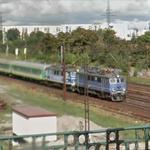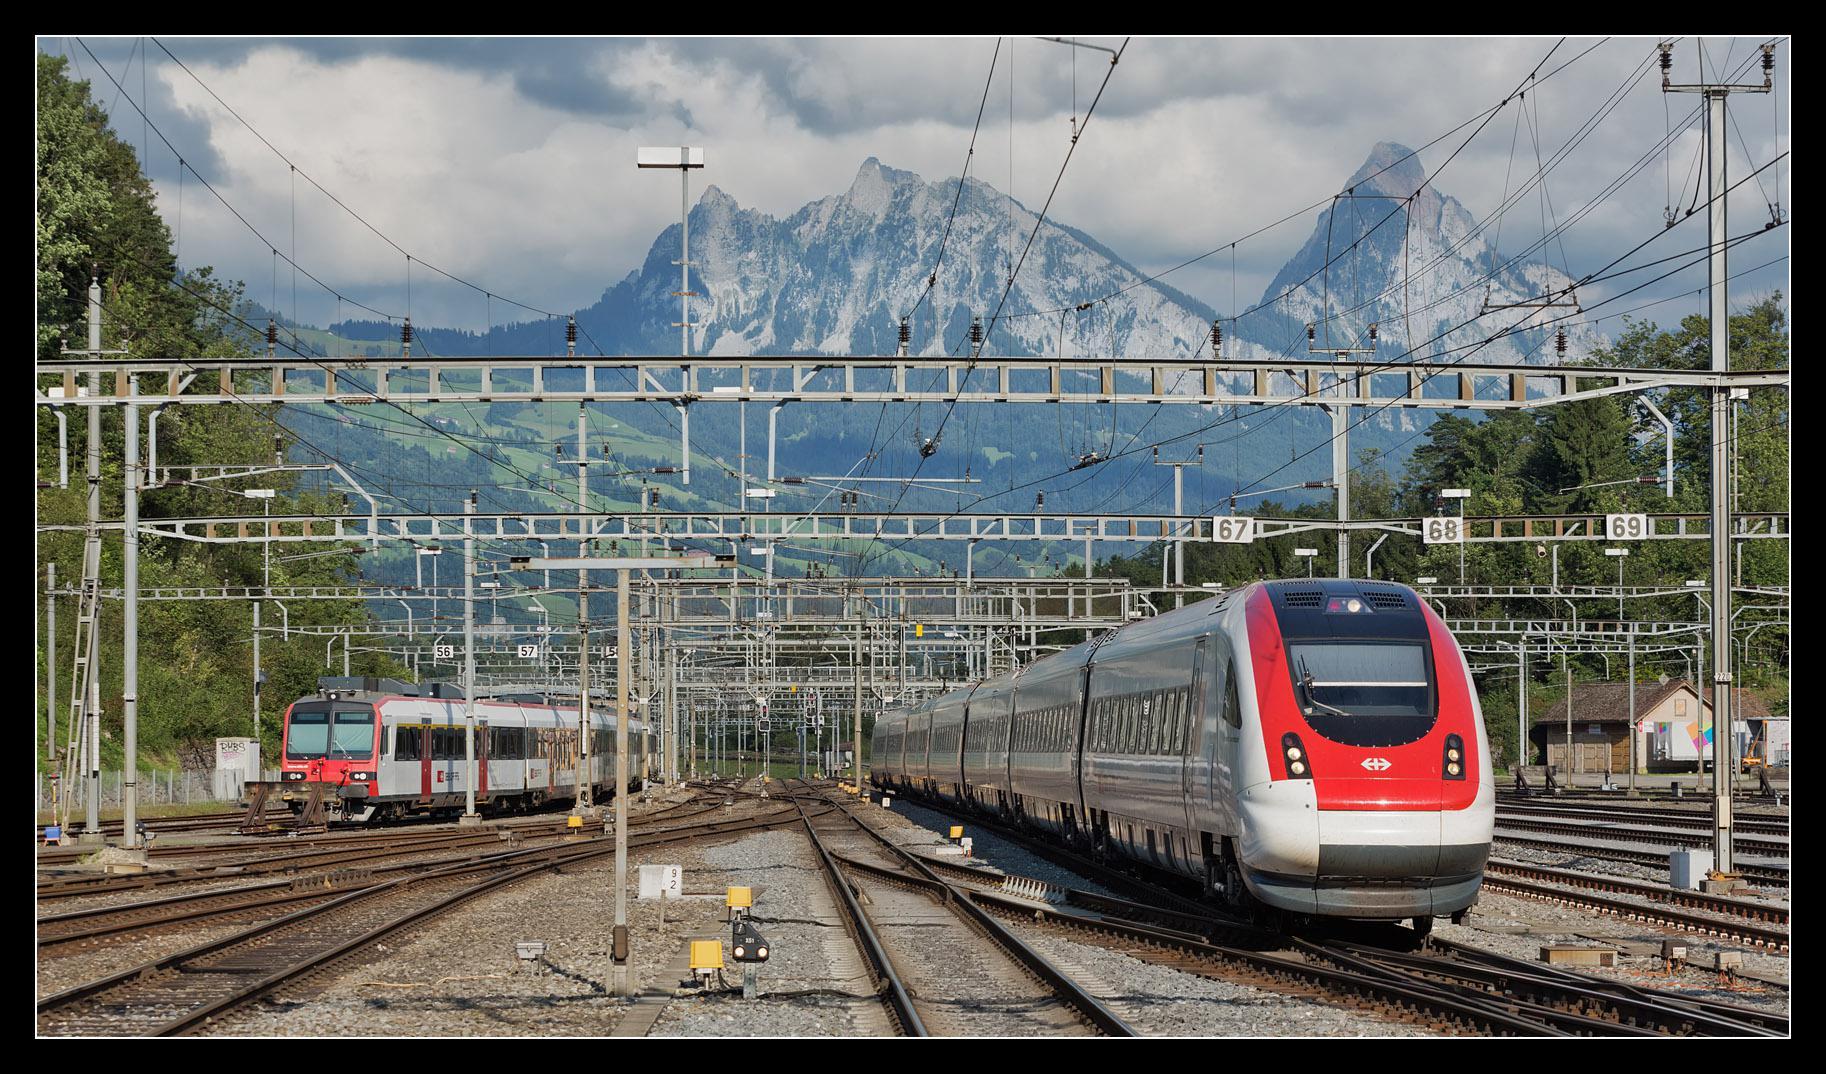The first image is the image on the left, the second image is the image on the right. Examine the images to the left and right. Is the description "The front car of the train in the right image has a red tint to it." accurate? Answer yes or no. Yes. The first image is the image on the left, the second image is the image on the right. Assess this claim about the two images: "there are two sets of trains in the right side image". Correct or not? Answer yes or no. Yes. 